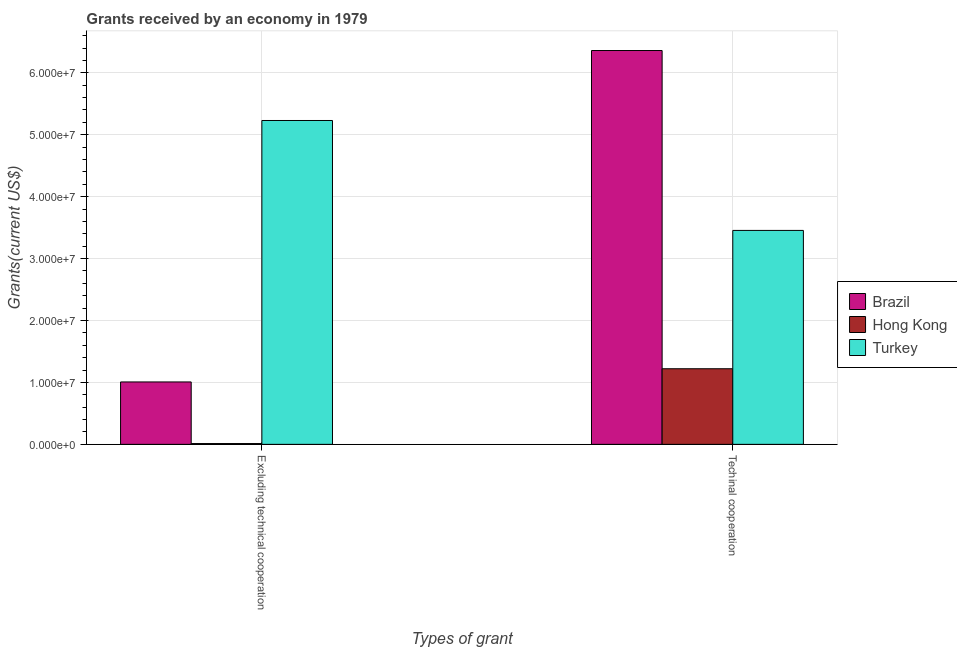How many different coloured bars are there?
Your answer should be compact. 3. How many groups of bars are there?
Make the answer very short. 2. How many bars are there on the 1st tick from the left?
Your response must be concise. 3. How many bars are there on the 1st tick from the right?
Keep it short and to the point. 3. What is the label of the 2nd group of bars from the left?
Your answer should be very brief. Techinal cooperation. What is the amount of grants received(excluding technical cooperation) in Turkey?
Make the answer very short. 5.23e+07. Across all countries, what is the maximum amount of grants received(excluding technical cooperation)?
Your answer should be very brief. 5.23e+07. Across all countries, what is the minimum amount of grants received(including technical cooperation)?
Make the answer very short. 1.22e+07. In which country was the amount of grants received(including technical cooperation) minimum?
Keep it short and to the point. Hong Kong. What is the total amount of grants received(excluding technical cooperation) in the graph?
Keep it short and to the point. 6.25e+07. What is the difference between the amount of grants received(including technical cooperation) in Brazil and that in Turkey?
Provide a short and direct response. 2.90e+07. What is the difference between the amount of grants received(including technical cooperation) in Hong Kong and the amount of grants received(excluding technical cooperation) in Turkey?
Keep it short and to the point. -4.01e+07. What is the average amount of grants received(including technical cooperation) per country?
Offer a terse response. 3.68e+07. What is the difference between the amount of grants received(excluding technical cooperation) and amount of grants received(including technical cooperation) in Hong Kong?
Keep it short and to the point. -1.21e+07. In how many countries, is the amount of grants received(including technical cooperation) greater than 4000000 US$?
Your response must be concise. 3. What is the ratio of the amount of grants received(including technical cooperation) in Hong Kong to that in Brazil?
Your answer should be compact. 0.19. What does the 2nd bar from the left in Excluding technical cooperation represents?
Ensure brevity in your answer.  Hong Kong. What does the 2nd bar from the right in Excluding technical cooperation represents?
Offer a very short reply. Hong Kong. How many bars are there?
Your response must be concise. 6. Are all the bars in the graph horizontal?
Make the answer very short. No. What is the difference between two consecutive major ticks on the Y-axis?
Your answer should be compact. 1.00e+07. Are the values on the major ticks of Y-axis written in scientific E-notation?
Offer a very short reply. Yes. Does the graph contain grids?
Your response must be concise. Yes. Where does the legend appear in the graph?
Your response must be concise. Center right. How many legend labels are there?
Ensure brevity in your answer.  3. What is the title of the graph?
Your response must be concise. Grants received by an economy in 1979. What is the label or title of the X-axis?
Give a very brief answer. Types of grant. What is the label or title of the Y-axis?
Your response must be concise. Grants(current US$). What is the Grants(current US$) of Brazil in Excluding technical cooperation?
Keep it short and to the point. 1.01e+07. What is the Grants(current US$) of Hong Kong in Excluding technical cooperation?
Keep it short and to the point. 1.30e+05. What is the Grants(current US$) of Turkey in Excluding technical cooperation?
Your response must be concise. 5.23e+07. What is the Grants(current US$) in Brazil in Techinal cooperation?
Ensure brevity in your answer.  6.36e+07. What is the Grants(current US$) in Hong Kong in Techinal cooperation?
Make the answer very short. 1.22e+07. What is the Grants(current US$) in Turkey in Techinal cooperation?
Your answer should be very brief. 3.46e+07. Across all Types of grant, what is the maximum Grants(current US$) of Brazil?
Keep it short and to the point. 6.36e+07. Across all Types of grant, what is the maximum Grants(current US$) of Hong Kong?
Offer a terse response. 1.22e+07. Across all Types of grant, what is the maximum Grants(current US$) in Turkey?
Offer a terse response. 5.23e+07. Across all Types of grant, what is the minimum Grants(current US$) of Brazil?
Offer a terse response. 1.01e+07. Across all Types of grant, what is the minimum Grants(current US$) in Hong Kong?
Provide a short and direct response. 1.30e+05. Across all Types of grant, what is the minimum Grants(current US$) of Turkey?
Give a very brief answer. 3.46e+07. What is the total Grants(current US$) of Brazil in the graph?
Ensure brevity in your answer.  7.37e+07. What is the total Grants(current US$) of Hong Kong in the graph?
Your answer should be compact. 1.23e+07. What is the total Grants(current US$) of Turkey in the graph?
Your response must be concise. 8.68e+07. What is the difference between the Grants(current US$) of Brazil in Excluding technical cooperation and that in Techinal cooperation?
Ensure brevity in your answer.  -5.35e+07. What is the difference between the Grants(current US$) of Hong Kong in Excluding technical cooperation and that in Techinal cooperation?
Your answer should be compact. -1.21e+07. What is the difference between the Grants(current US$) of Turkey in Excluding technical cooperation and that in Techinal cooperation?
Make the answer very short. 1.78e+07. What is the difference between the Grants(current US$) in Brazil in Excluding technical cooperation and the Grants(current US$) in Hong Kong in Techinal cooperation?
Provide a short and direct response. -2.13e+06. What is the difference between the Grants(current US$) in Brazil in Excluding technical cooperation and the Grants(current US$) in Turkey in Techinal cooperation?
Offer a very short reply. -2.45e+07. What is the difference between the Grants(current US$) in Hong Kong in Excluding technical cooperation and the Grants(current US$) in Turkey in Techinal cooperation?
Your answer should be compact. -3.44e+07. What is the average Grants(current US$) of Brazil per Types of grant?
Provide a short and direct response. 3.68e+07. What is the average Grants(current US$) of Hong Kong per Types of grant?
Make the answer very short. 6.17e+06. What is the average Grants(current US$) of Turkey per Types of grant?
Your answer should be very brief. 4.34e+07. What is the difference between the Grants(current US$) in Brazil and Grants(current US$) in Hong Kong in Excluding technical cooperation?
Give a very brief answer. 9.95e+06. What is the difference between the Grants(current US$) in Brazil and Grants(current US$) in Turkey in Excluding technical cooperation?
Offer a terse response. -4.22e+07. What is the difference between the Grants(current US$) in Hong Kong and Grants(current US$) in Turkey in Excluding technical cooperation?
Your answer should be very brief. -5.22e+07. What is the difference between the Grants(current US$) of Brazil and Grants(current US$) of Hong Kong in Techinal cooperation?
Your answer should be very brief. 5.14e+07. What is the difference between the Grants(current US$) in Brazil and Grants(current US$) in Turkey in Techinal cooperation?
Provide a succinct answer. 2.90e+07. What is the difference between the Grants(current US$) in Hong Kong and Grants(current US$) in Turkey in Techinal cooperation?
Make the answer very short. -2.23e+07. What is the ratio of the Grants(current US$) in Brazil in Excluding technical cooperation to that in Techinal cooperation?
Provide a short and direct response. 0.16. What is the ratio of the Grants(current US$) of Hong Kong in Excluding technical cooperation to that in Techinal cooperation?
Give a very brief answer. 0.01. What is the ratio of the Grants(current US$) of Turkey in Excluding technical cooperation to that in Techinal cooperation?
Keep it short and to the point. 1.51. What is the difference between the highest and the second highest Grants(current US$) of Brazil?
Ensure brevity in your answer.  5.35e+07. What is the difference between the highest and the second highest Grants(current US$) of Hong Kong?
Provide a succinct answer. 1.21e+07. What is the difference between the highest and the second highest Grants(current US$) of Turkey?
Give a very brief answer. 1.78e+07. What is the difference between the highest and the lowest Grants(current US$) of Brazil?
Offer a terse response. 5.35e+07. What is the difference between the highest and the lowest Grants(current US$) in Hong Kong?
Offer a very short reply. 1.21e+07. What is the difference between the highest and the lowest Grants(current US$) in Turkey?
Provide a short and direct response. 1.78e+07. 